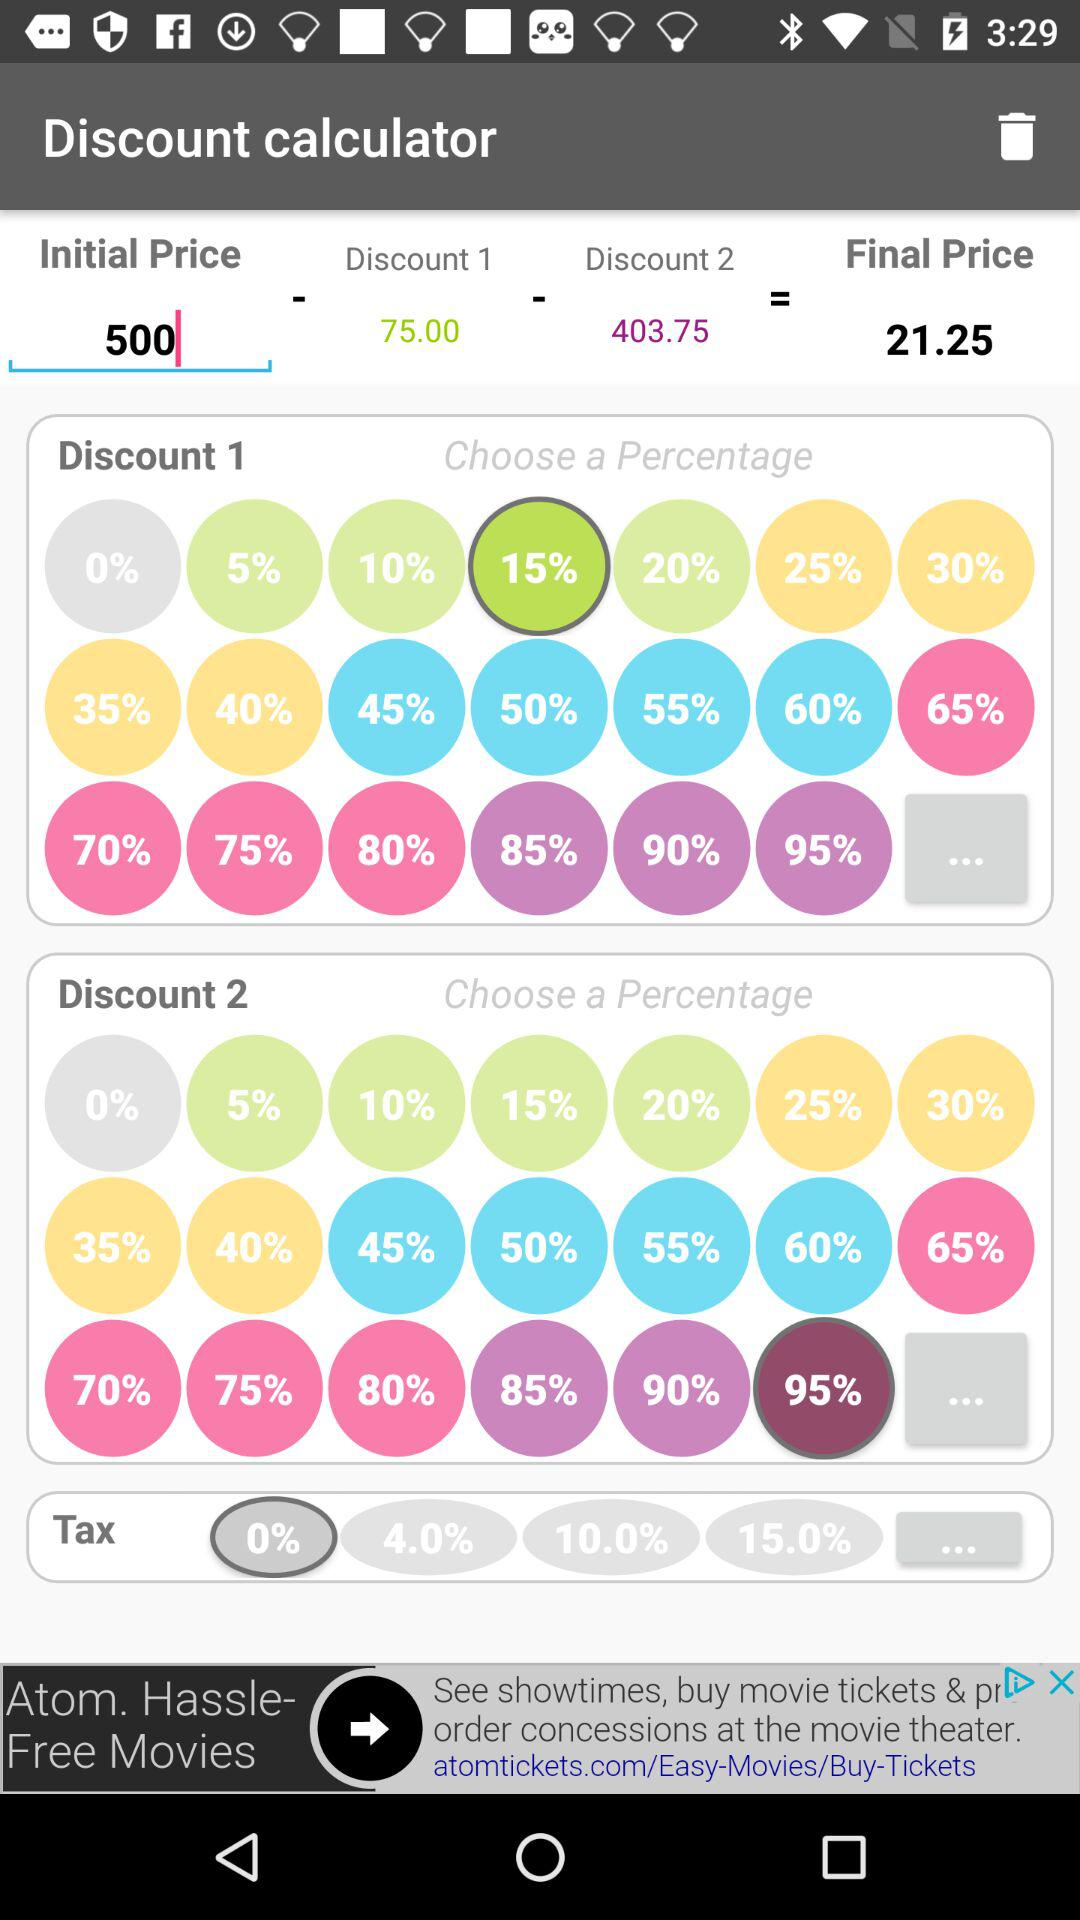What is the value in "Discount 1"? The value in "Discount 1" is 75. 